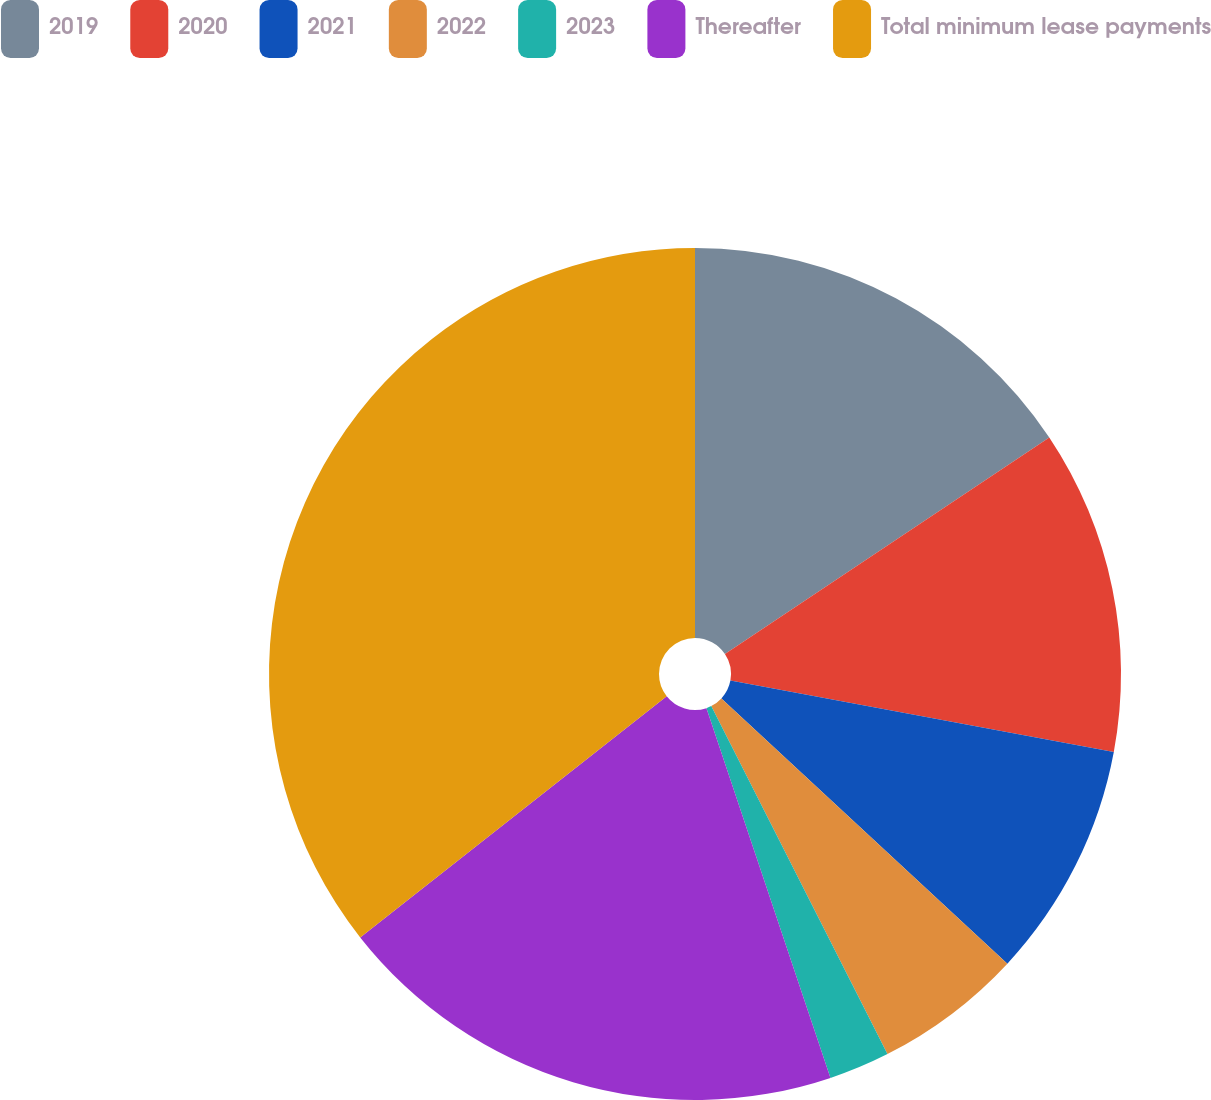Convert chart to OTSL. <chart><loc_0><loc_0><loc_500><loc_500><pie_chart><fcel>2019<fcel>2020<fcel>2021<fcel>2022<fcel>2023<fcel>Thereafter<fcel>Total minimum lease payments<nl><fcel>15.63%<fcel>12.3%<fcel>8.97%<fcel>5.64%<fcel>2.31%<fcel>19.54%<fcel>35.61%<nl></chart> 